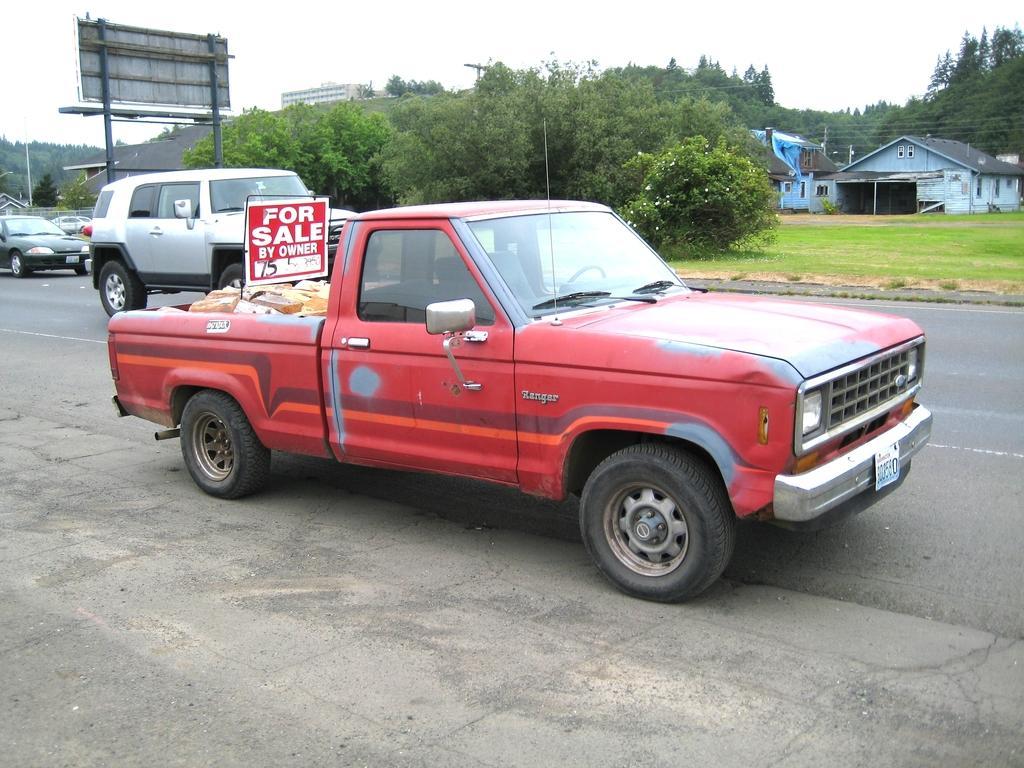Describe this image in one or two sentences. There is a truck parked beside the road and some goods are kept in the truck for sale and behind the truck there are some vehicles moving on the road,on the other side of the road there are plenty of trees and few houses. 